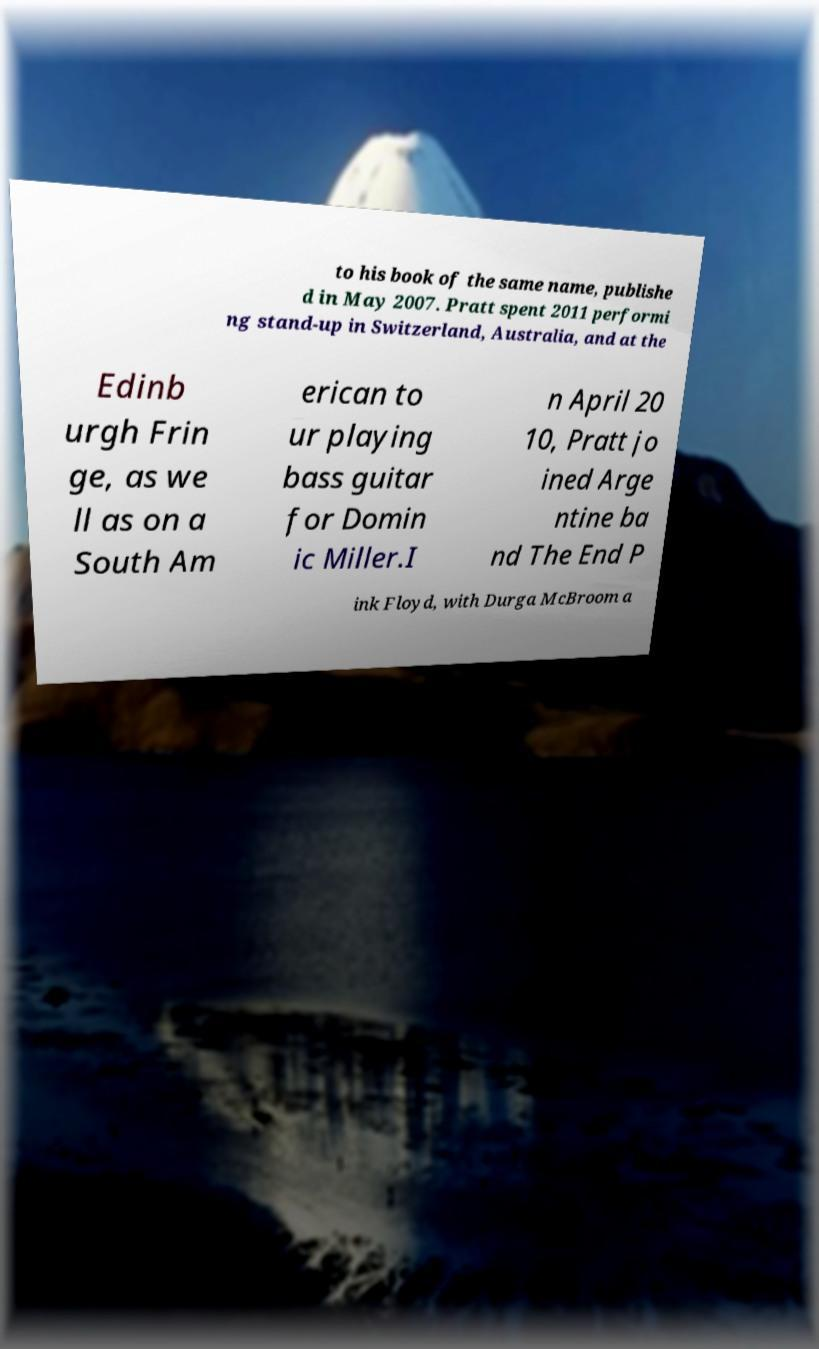I need the written content from this picture converted into text. Can you do that? to his book of the same name, publishe d in May 2007. Pratt spent 2011 performi ng stand-up in Switzerland, Australia, and at the Edinb urgh Frin ge, as we ll as on a South Am erican to ur playing bass guitar for Domin ic Miller.I n April 20 10, Pratt jo ined Arge ntine ba nd The End P ink Floyd, with Durga McBroom a 